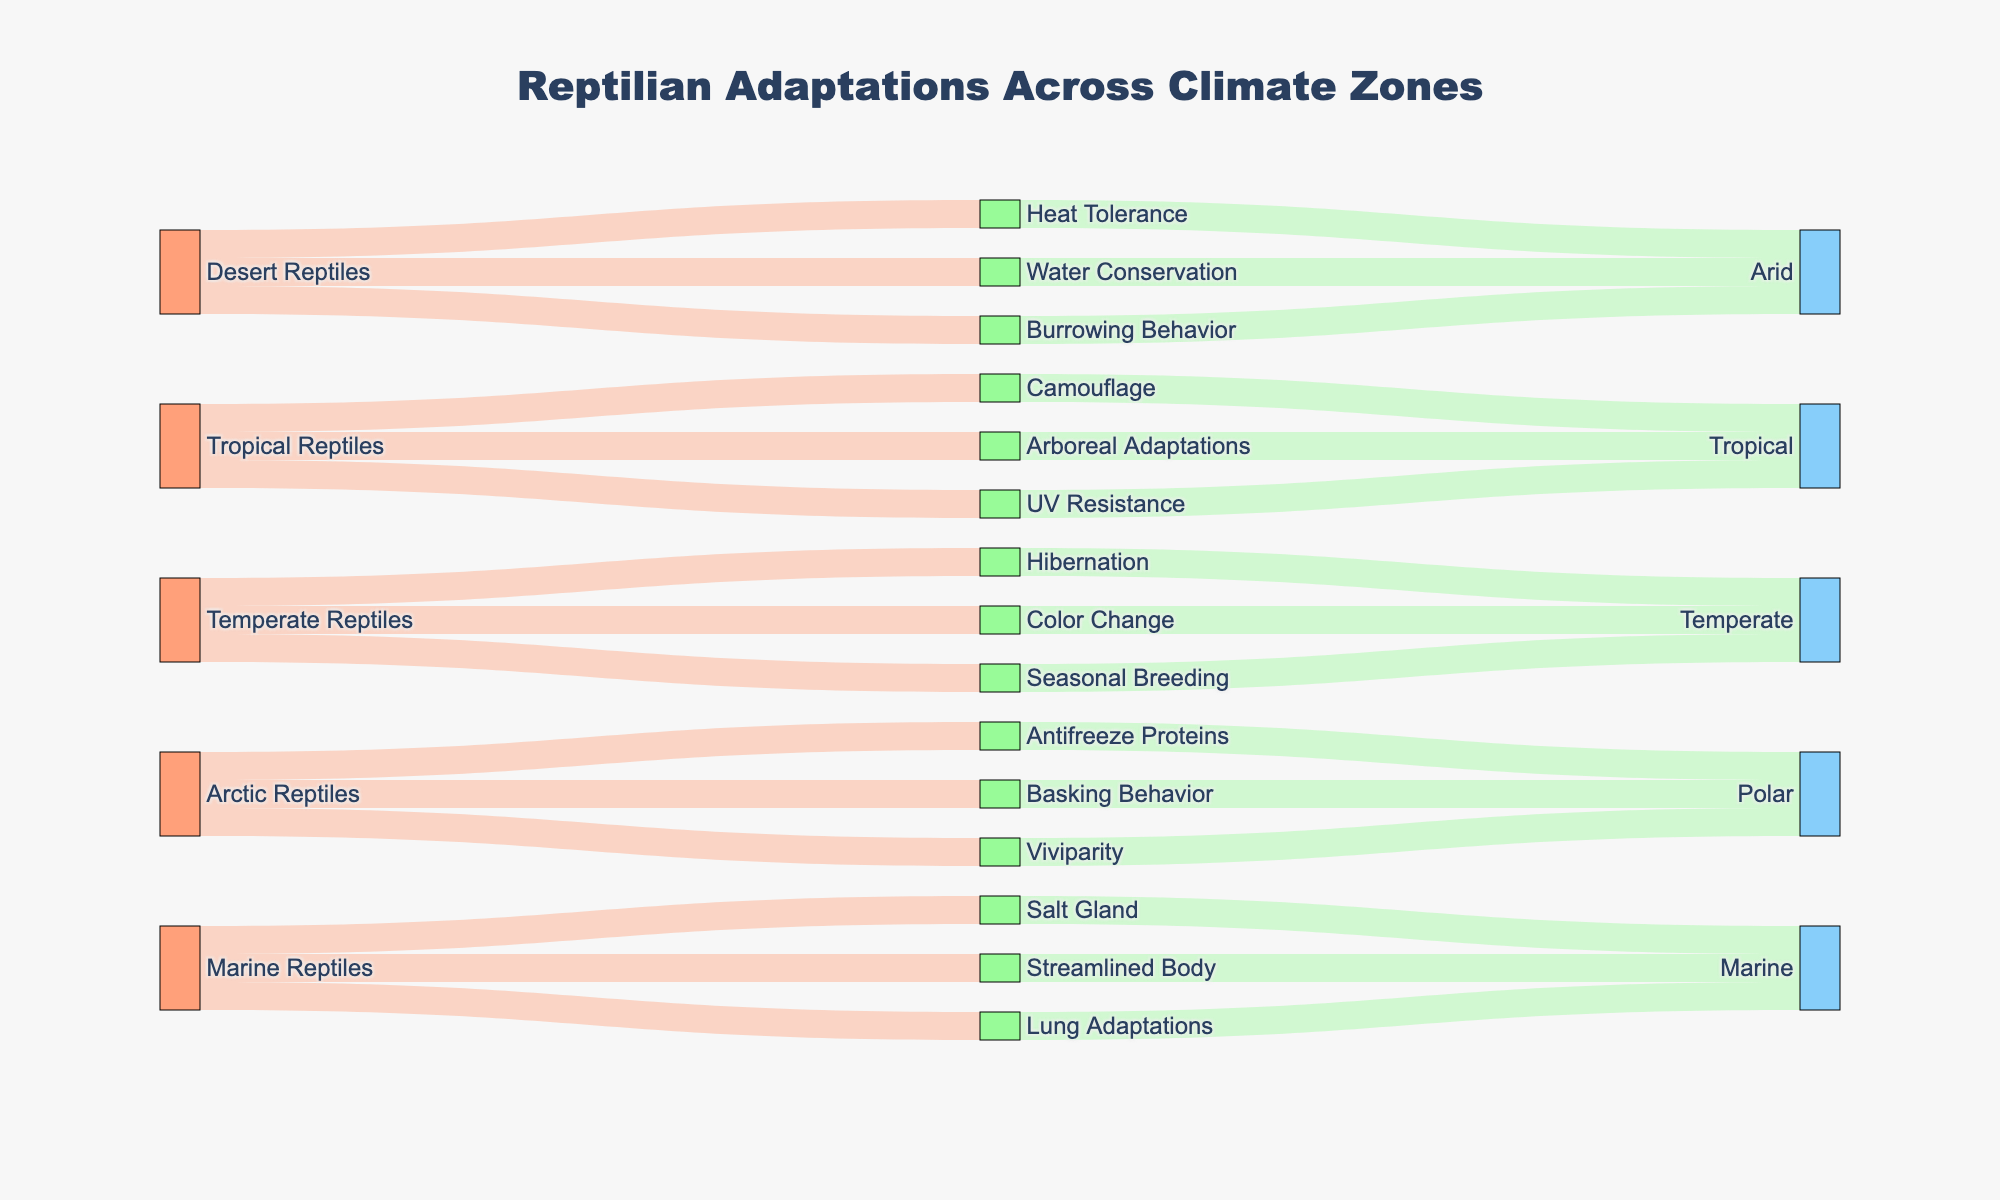What is the title of the figure? The title is located at the top center of the diagram and provides a summary of the content.
Answer: Reptilian Adaptations Across Climate Zones How many types of reptilian adaptations are shown for Arctic reptiles? Look at the labels under Arctic Reptiles in the "Source" column and count the number of unique adaptations linked to Arctic Reptiles.
Answer: Three Which climate zone has reptiles with heat tolerance as an adaptation? Trace the link from the "Heat Tolerance" adaptation to its associated climate zone.
Answer: Arid How many total climate zones are represented in the figure? Look at the labels in the "Climate Zone" column and count the unique climate zones listed.
Answer: Four Which reptilian adaptation is common across the most climate zones? Identify the adaptation labels and count the number of unique climate zones each adaptation is linked to. The adaptation with the highest count is the answer.
Answer: Each adaptation is unique to its climate zone What is the total number of distinct adaptations shown in the figure? Count each unique adaptation label in the diagram.
Answer: Twelve Are more adaptations shown for Tropical reptiles or Temperate reptiles? Compare the number of adaptations linked under the labels for Tropical Reptiles and Temperate Reptiles.
Answer: Tropical Which climate zone has reptiles that exhibit burrowing behavior? Follow the link from "Burrowing Behavior" and identify the associated climate zone.
Answer: Arid Which adaptation is associated with both color change and seasonal breeding? Look under the list of adaptations linked to Temperate Reptiles and identify those associated specifically with color change and seasonal breeding.
Answer: Temperate Are there any climate zones with fewer than three adaptations? Count adaptations linked to each climate zone and identify any with fewer than three adaptations.
Answer: No 